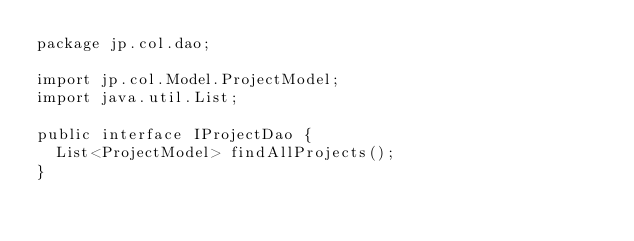Convert code to text. <code><loc_0><loc_0><loc_500><loc_500><_Java_>package jp.col.dao;

import jp.col.Model.ProjectModel;
import java.util.List;

public interface IProjectDao {
	List<ProjectModel> findAllProjects();
}</code> 